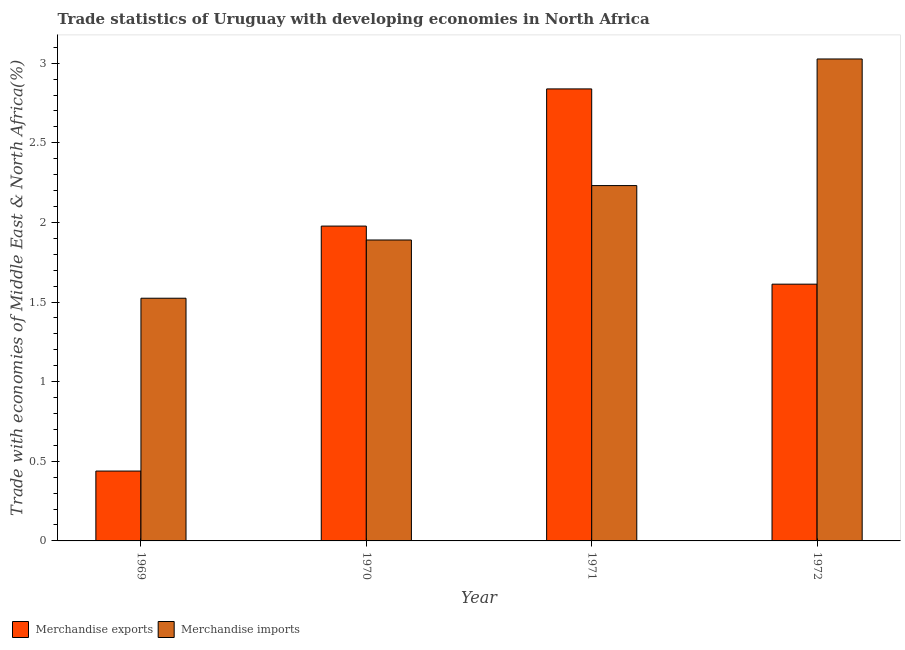How many groups of bars are there?
Your answer should be very brief. 4. How many bars are there on the 4th tick from the left?
Offer a very short reply. 2. What is the label of the 1st group of bars from the left?
Offer a terse response. 1969. What is the merchandise exports in 1972?
Provide a short and direct response. 1.61. Across all years, what is the maximum merchandise exports?
Give a very brief answer. 2.84. Across all years, what is the minimum merchandise exports?
Give a very brief answer. 0.44. In which year was the merchandise imports minimum?
Your answer should be compact. 1969. What is the total merchandise exports in the graph?
Your answer should be very brief. 6.87. What is the difference between the merchandise imports in 1970 and that in 1971?
Your answer should be compact. -0.34. What is the difference between the merchandise exports in 1972 and the merchandise imports in 1970?
Provide a short and direct response. -0.36. What is the average merchandise exports per year?
Provide a short and direct response. 1.72. In how many years, is the merchandise imports greater than 2.8 %?
Make the answer very short. 1. What is the ratio of the merchandise imports in 1969 to that in 1972?
Offer a terse response. 0.5. What is the difference between the highest and the second highest merchandise exports?
Keep it short and to the point. 0.86. What is the difference between the highest and the lowest merchandise exports?
Provide a succinct answer. 2.4. Is the sum of the merchandise exports in 1971 and 1972 greater than the maximum merchandise imports across all years?
Offer a very short reply. Yes. What does the 1st bar from the right in 1971 represents?
Make the answer very short. Merchandise imports. How many years are there in the graph?
Your answer should be compact. 4. Does the graph contain any zero values?
Keep it short and to the point. No. What is the title of the graph?
Offer a very short reply. Trade statistics of Uruguay with developing economies in North Africa. Does "Food and tobacco" appear as one of the legend labels in the graph?
Give a very brief answer. No. What is the label or title of the X-axis?
Your answer should be very brief. Year. What is the label or title of the Y-axis?
Provide a succinct answer. Trade with economies of Middle East & North Africa(%). What is the Trade with economies of Middle East & North Africa(%) of Merchandise exports in 1969?
Keep it short and to the point. 0.44. What is the Trade with economies of Middle East & North Africa(%) in Merchandise imports in 1969?
Your response must be concise. 1.52. What is the Trade with economies of Middle East & North Africa(%) of Merchandise exports in 1970?
Make the answer very short. 1.98. What is the Trade with economies of Middle East & North Africa(%) of Merchandise imports in 1970?
Your answer should be compact. 1.89. What is the Trade with economies of Middle East & North Africa(%) of Merchandise exports in 1971?
Your response must be concise. 2.84. What is the Trade with economies of Middle East & North Africa(%) of Merchandise imports in 1971?
Provide a succinct answer. 2.23. What is the Trade with economies of Middle East & North Africa(%) of Merchandise exports in 1972?
Keep it short and to the point. 1.61. What is the Trade with economies of Middle East & North Africa(%) of Merchandise imports in 1972?
Give a very brief answer. 3.03. Across all years, what is the maximum Trade with economies of Middle East & North Africa(%) of Merchandise exports?
Offer a terse response. 2.84. Across all years, what is the maximum Trade with economies of Middle East & North Africa(%) in Merchandise imports?
Give a very brief answer. 3.03. Across all years, what is the minimum Trade with economies of Middle East & North Africa(%) in Merchandise exports?
Your answer should be very brief. 0.44. Across all years, what is the minimum Trade with economies of Middle East & North Africa(%) of Merchandise imports?
Keep it short and to the point. 1.52. What is the total Trade with economies of Middle East & North Africa(%) of Merchandise exports in the graph?
Your answer should be compact. 6.87. What is the total Trade with economies of Middle East & North Africa(%) of Merchandise imports in the graph?
Keep it short and to the point. 8.67. What is the difference between the Trade with economies of Middle East & North Africa(%) of Merchandise exports in 1969 and that in 1970?
Keep it short and to the point. -1.54. What is the difference between the Trade with economies of Middle East & North Africa(%) of Merchandise imports in 1969 and that in 1970?
Your response must be concise. -0.37. What is the difference between the Trade with economies of Middle East & North Africa(%) of Merchandise exports in 1969 and that in 1971?
Your answer should be compact. -2.4. What is the difference between the Trade with economies of Middle East & North Africa(%) in Merchandise imports in 1969 and that in 1971?
Provide a short and direct response. -0.71. What is the difference between the Trade with economies of Middle East & North Africa(%) of Merchandise exports in 1969 and that in 1972?
Provide a short and direct response. -1.17. What is the difference between the Trade with economies of Middle East & North Africa(%) in Merchandise imports in 1969 and that in 1972?
Offer a terse response. -1.5. What is the difference between the Trade with economies of Middle East & North Africa(%) of Merchandise exports in 1970 and that in 1971?
Make the answer very short. -0.86. What is the difference between the Trade with economies of Middle East & North Africa(%) in Merchandise imports in 1970 and that in 1971?
Your answer should be very brief. -0.34. What is the difference between the Trade with economies of Middle East & North Africa(%) of Merchandise exports in 1970 and that in 1972?
Keep it short and to the point. 0.36. What is the difference between the Trade with economies of Middle East & North Africa(%) of Merchandise imports in 1970 and that in 1972?
Your response must be concise. -1.14. What is the difference between the Trade with economies of Middle East & North Africa(%) of Merchandise exports in 1971 and that in 1972?
Provide a succinct answer. 1.23. What is the difference between the Trade with economies of Middle East & North Africa(%) in Merchandise imports in 1971 and that in 1972?
Your answer should be compact. -0.8. What is the difference between the Trade with economies of Middle East & North Africa(%) of Merchandise exports in 1969 and the Trade with economies of Middle East & North Africa(%) of Merchandise imports in 1970?
Provide a short and direct response. -1.45. What is the difference between the Trade with economies of Middle East & North Africa(%) of Merchandise exports in 1969 and the Trade with economies of Middle East & North Africa(%) of Merchandise imports in 1971?
Your answer should be compact. -1.79. What is the difference between the Trade with economies of Middle East & North Africa(%) in Merchandise exports in 1969 and the Trade with economies of Middle East & North Africa(%) in Merchandise imports in 1972?
Offer a very short reply. -2.59. What is the difference between the Trade with economies of Middle East & North Africa(%) in Merchandise exports in 1970 and the Trade with economies of Middle East & North Africa(%) in Merchandise imports in 1971?
Your response must be concise. -0.25. What is the difference between the Trade with economies of Middle East & North Africa(%) of Merchandise exports in 1970 and the Trade with economies of Middle East & North Africa(%) of Merchandise imports in 1972?
Offer a very short reply. -1.05. What is the difference between the Trade with economies of Middle East & North Africa(%) in Merchandise exports in 1971 and the Trade with economies of Middle East & North Africa(%) in Merchandise imports in 1972?
Provide a succinct answer. -0.19. What is the average Trade with economies of Middle East & North Africa(%) of Merchandise exports per year?
Ensure brevity in your answer.  1.72. What is the average Trade with economies of Middle East & North Africa(%) of Merchandise imports per year?
Offer a terse response. 2.17. In the year 1969, what is the difference between the Trade with economies of Middle East & North Africa(%) in Merchandise exports and Trade with economies of Middle East & North Africa(%) in Merchandise imports?
Offer a very short reply. -1.09. In the year 1970, what is the difference between the Trade with economies of Middle East & North Africa(%) in Merchandise exports and Trade with economies of Middle East & North Africa(%) in Merchandise imports?
Make the answer very short. 0.09. In the year 1971, what is the difference between the Trade with economies of Middle East & North Africa(%) of Merchandise exports and Trade with economies of Middle East & North Africa(%) of Merchandise imports?
Offer a terse response. 0.61. In the year 1972, what is the difference between the Trade with economies of Middle East & North Africa(%) of Merchandise exports and Trade with economies of Middle East & North Africa(%) of Merchandise imports?
Offer a very short reply. -1.41. What is the ratio of the Trade with economies of Middle East & North Africa(%) of Merchandise exports in 1969 to that in 1970?
Offer a very short reply. 0.22. What is the ratio of the Trade with economies of Middle East & North Africa(%) of Merchandise imports in 1969 to that in 1970?
Offer a very short reply. 0.81. What is the ratio of the Trade with economies of Middle East & North Africa(%) of Merchandise exports in 1969 to that in 1971?
Provide a short and direct response. 0.15. What is the ratio of the Trade with economies of Middle East & North Africa(%) in Merchandise imports in 1969 to that in 1971?
Your response must be concise. 0.68. What is the ratio of the Trade with economies of Middle East & North Africa(%) in Merchandise exports in 1969 to that in 1972?
Keep it short and to the point. 0.27. What is the ratio of the Trade with economies of Middle East & North Africa(%) in Merchandise imports in 1969 to that in 1972?
Ensure brevity in your answer.  0.5. What is the ratio of the Trade with economies of Middle East & North Africa(%) in Merchandise exports in 1970 to that in 1971?
Your response must be concise. 0.7. What is the ratio of the Trade with economies of Middle East & North Africa(%) in Merchandise imports in 1970 to that in 1971?
Provide a succinct answer. 0.85. What is the ratio of the Trade with economies of Middle East & North Africa(%) in Merchandise exports in 1970 to that in 1972?
Give a very brief answer. 1.23. What is the ratio of the Trade with economies of Middle East & North Africa(%) in Merchandise imports in 1970 to that in 1972?
Offer a terse response. 0.62. What is the ratio of the Trade with economies of Middle East & North Africa(%) in Merchandise exports in 1971 to that in 1972?
Offer a very short reply. 1.76. What is the ratio of the Trade with economies of Middle East & North Africa(%) of Merchandise imports in 1971 to that in 1972?
Give a very brief answer. 0.74. What is the difference between the highest and the second highest Trade with economies of Middle East & North Africa(%) of Merchandise exports?
Your response must be concise. 0.86. What is the difference between the highest and the second highest Trade with economies of Middle East & North Africa(%) in Merchandise imports?
Your answer should be very brief. 0.8. What is the difference between the highest and the lowest Trade with economies of Middle East & North Africa(%) in Merchandise exports?
Your response must be concise. 2.4. What is the difference between the highest and the lowest Trade with economies of Middle East & North Africa(%) of Merchandise imports?
Offer a very short reply. 1.5. 